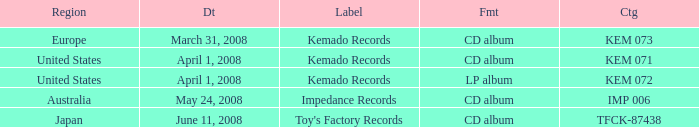Which Region has a Catalog of kem 072? United States. 